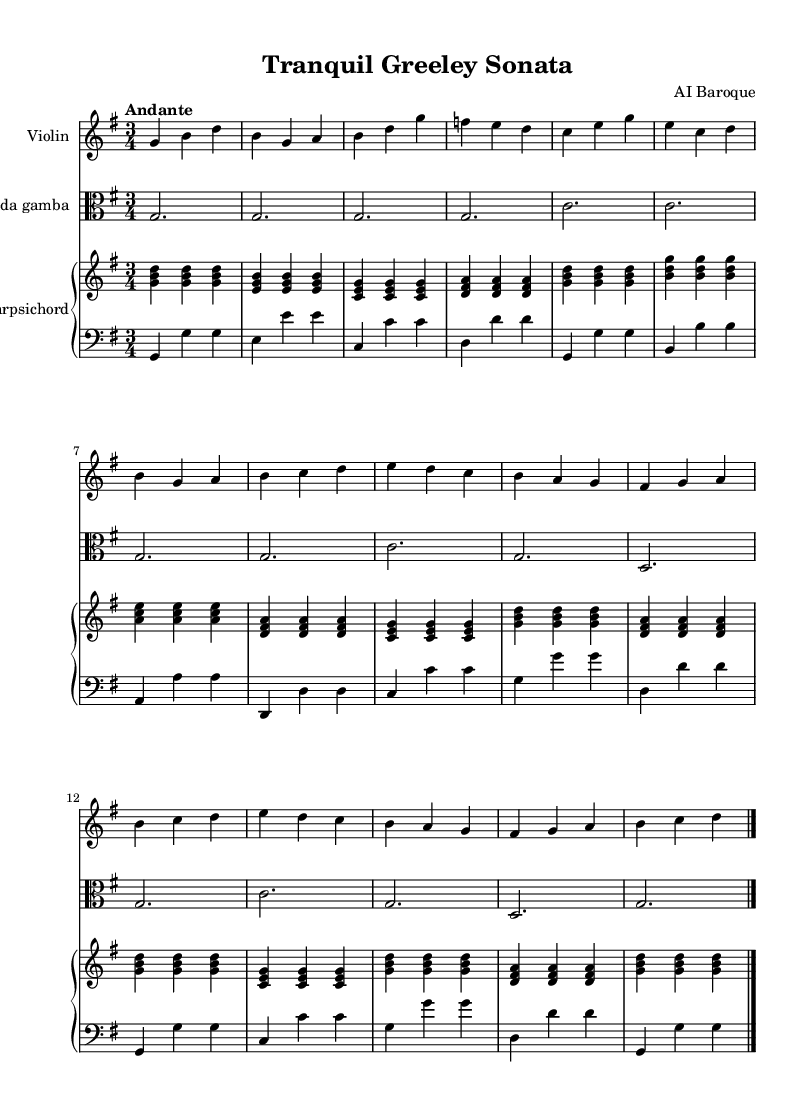What is the key signature of this music? The key signature is G major, which has one sharp (F#). You can determine this by looking at the key signature indicated at the beginning of the sheet music.
Answer: G major What is the time signature of the piece? The time signature is 3/4, indicated at the start of the music. This means there are three beats in each measure, and a quarter note receives one beat.
Answer: 3/4 What is the tempo marking for this piece? The tempo marking is Andante, indicating a moderately slow tempo. This is also noted at the beginning of the sheet music.
Answer: Andante How many measures are in the violin part? There are 14 measures in the violin part. You can find this by counting each individual measure marked by vertical lines in that staff.
Answer: 14 What instrument plays the alto clef? The instrument that plays the alto clef in this score is the Viola da gamba. The clef is specified at the beginning of the viola staff.
Answer: Viola da gamba Which instruments are included in this chamber music piece? The instruments included are the Violin, Viola da gamba, and Harpsichord. You can see the names of the instruments at the beginning of each staff in the score.
Answer: Violin, Viola da gamba, Harpsichord 